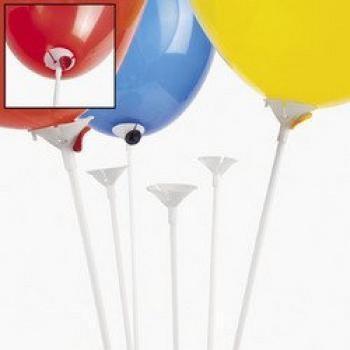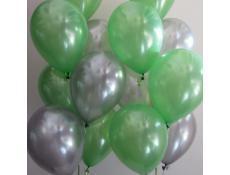The first image is the image on the left, the second image is the image on the right. For the images displayed, is the sentence "there are plastick baloon holders insteas of ribbons" factually correct? Answer yes or no. Yes. 